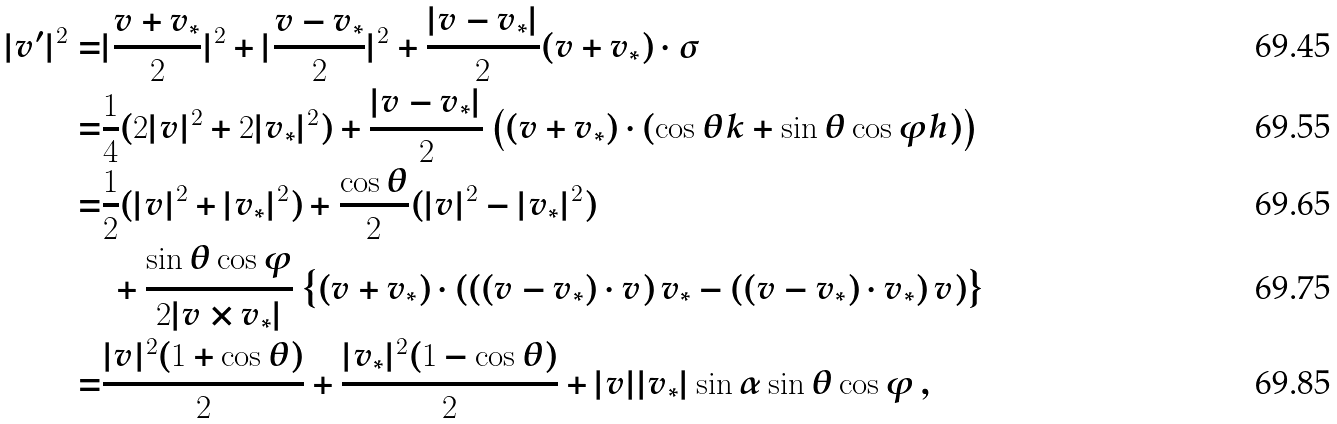<formula> <loc_0><loc_0><loc_500><loc_500>| v ^ { \prime } | ^ { 2 } = & | \frac { v + v _ { * } } { 2 } | ^ { 2 } + | \frac { v - v _ { * } } { 2 } | ^ { 2 } + \frac { | v - v _ { * } | } { 2 } ( v + v _ { * } ) \cdot \sigma \\ \quad = & \frac { 1 } { 4 } ( 2 | v | ^ { 2 } + 2 | v _ { * } | ^ { 2 } ) + \frac { | v - v _ { * } | } { 2 } \left ( ( v + v _ { * } ) \cdot ( \cos \theta k + \sin \theta \cos \varphi h ) \right ) \\ \quad = & \frac { 1 } { 2 } ( | v | ^ { 2 } + | v _ { * } | ^ { 2 } ) + \frac { \cos \theta } { 2 } ( | v | ^ { 2 } - | v _ { * } | ^ { 2 } ) \\ & \ + \frac { \sin \theta \cos \varphi } { 2 | v \times v _ { * } | } \left \{ ( v + v _ { * } ) \cdot \left ( \left ( ( v - v _ { * } ) \cdot v \right ) v _ { * } - \left ( ( v - v _ { * } ) \cdot v _ { * } \right ) v \right ) \right \} \\ = & \frac { | v | ^ { 2 } ( 1 + \cos \theta ) } { 2 } + \frac { | v _ { * } | ^ { 2 } ( 1 - \cos \theta ) } { 2 } + | v | | v _ { * } | \sin \alpha \sin \theta \cos \varphi \, ,</formula> 